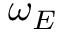Convert formula to latex. <formula><loc_0><loc_0><loc_500><loc_500>\omega _ { E }</formula> 